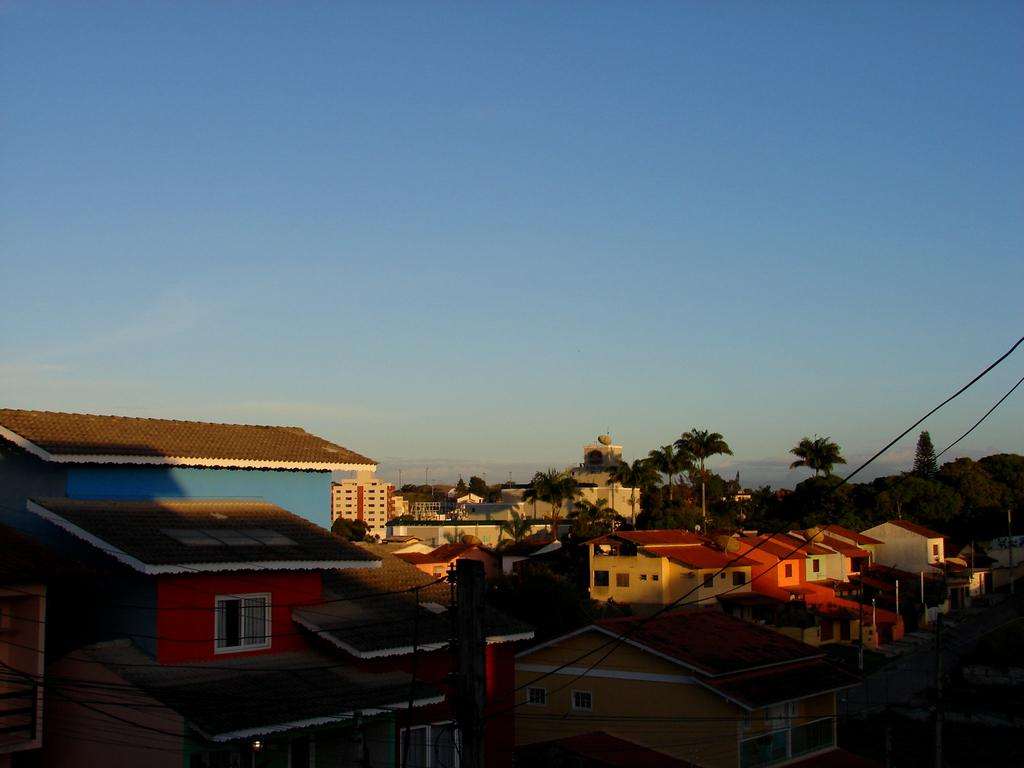What type of structures can be seen in the image? There are houses in the image. What type of vegetation is present in the image? There are trees in the image. What type of man-made objects can be seen in the image? There are poles in the image. What are the poles supporting in the image? The poles are supporting wires in the image. What is visible in the background of the image? The sky is visible in the background of the image. What type of collar can be seen on the trees in the image? There are no collars present on the trees in the image. What type of smell can be detected from the image? There is no information about smells in the image. What type of suggestion can be made based on the image? There is no specific suggestion that can be made based solely on the image. 